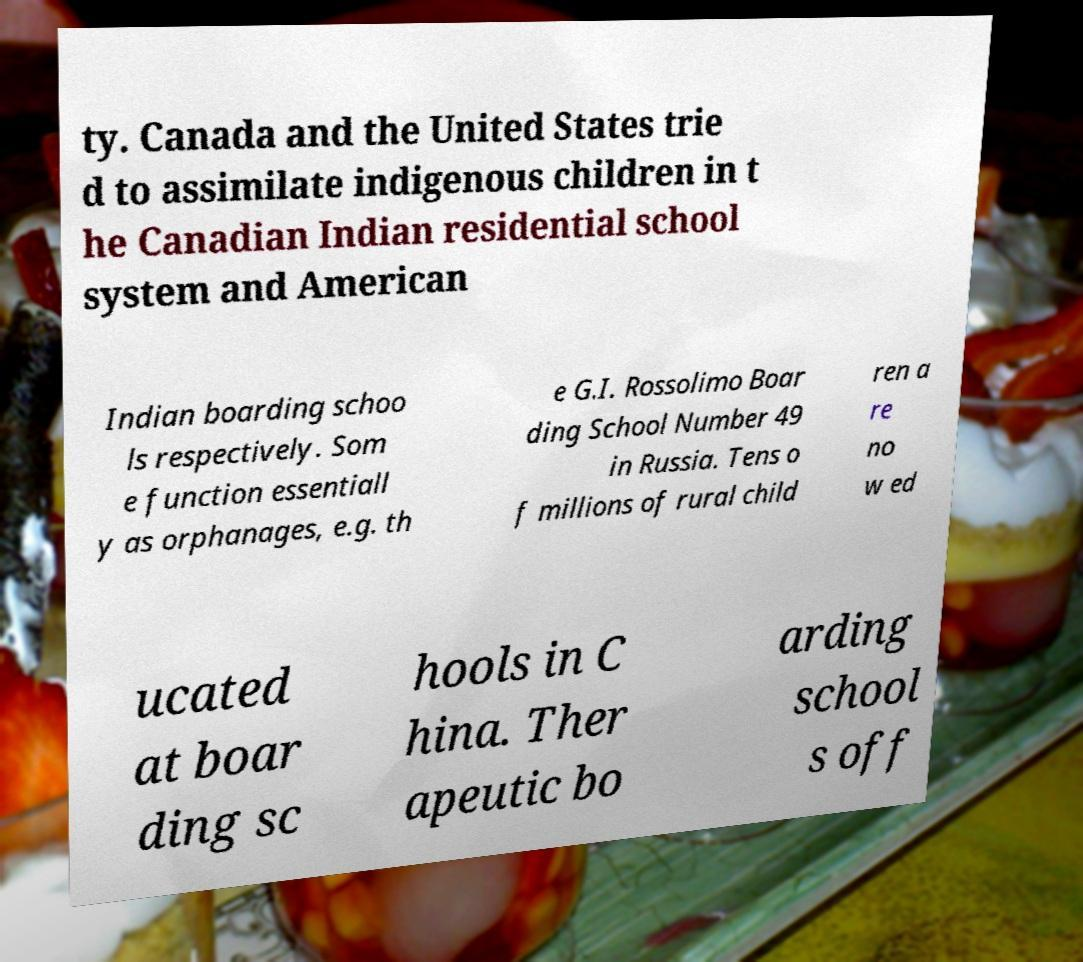For documentation purposes, I need the text within this image transcribed. Could you provide that? ty. Canada and the United States trie d to assimilate indigenous children in t he Canadian Indian residential school system and American Indian boarding schoo ls respectively. Som e function essentiall y as orphanages, e.g. th e G.I. Rossolimo Boar ding School Number 49 in Russia. Tens o f millions of rural child ren a re no w ed ucated at boar ding sc hools in C hina. Ther apeutic bo arding school s off 